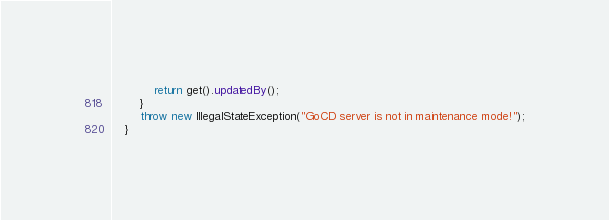Convert code to text. <code><loc_0><loc_0><loc_500><loc_500><_Java_>            return get().updatedBy();
        }
        throw new IllegalStateException("GoCD server is not in maintenance mode!");
    }
</code> 